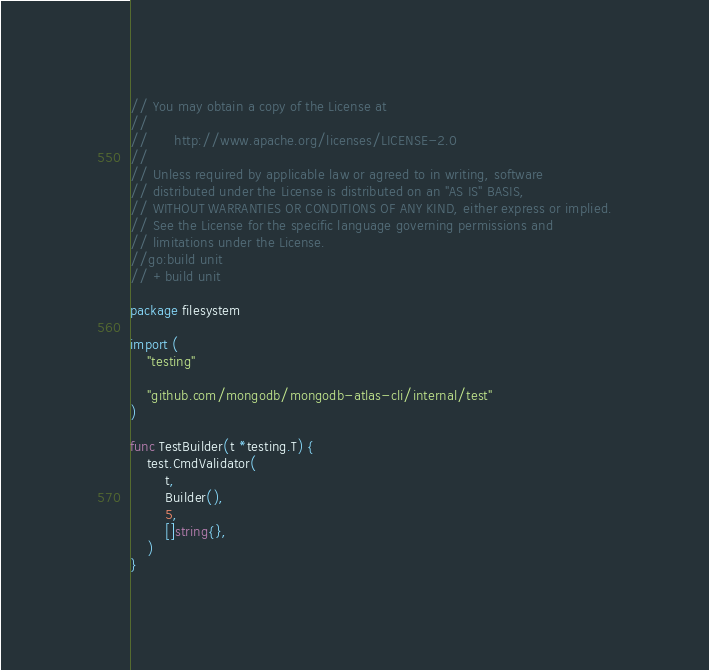Convert code to text. <code><loc_0><loc_0><loc_500><loc_500><_Go_>// You may obtain a copy of the License at
//
//      http://www.apache.org/licenses/LICENSE-2.0
//
// Unless required by applicable law or agreed to in writing, software
// distributed under the License is distributed on an "AS IS" BASIS,
// WITHOUT WARRANTIES OR CONDITIONS OF ANY KIND, either express or implied.
// See the License for the specific language governing permissions and
// limitations under the License.
//go:build unit
// +build unit

package filesystem

import (
	"testing"

	"github.com/mongodb/mongodb-atlas-cli/internal/test"
)

func TestBuilder(t *testing.T) {
	test.CmdValidator(
		t,
		Builder(),
		5,
		[]string{},
	)
}
</code> 